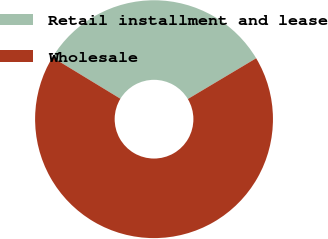<chart> <loc_0><loc_0><loc_500><loc_500><pie_chart><fcel>Retail installment and lease<fcel>Wholesale<nl><fcel>32.74%<fcel>67.26%<nl></chart> 